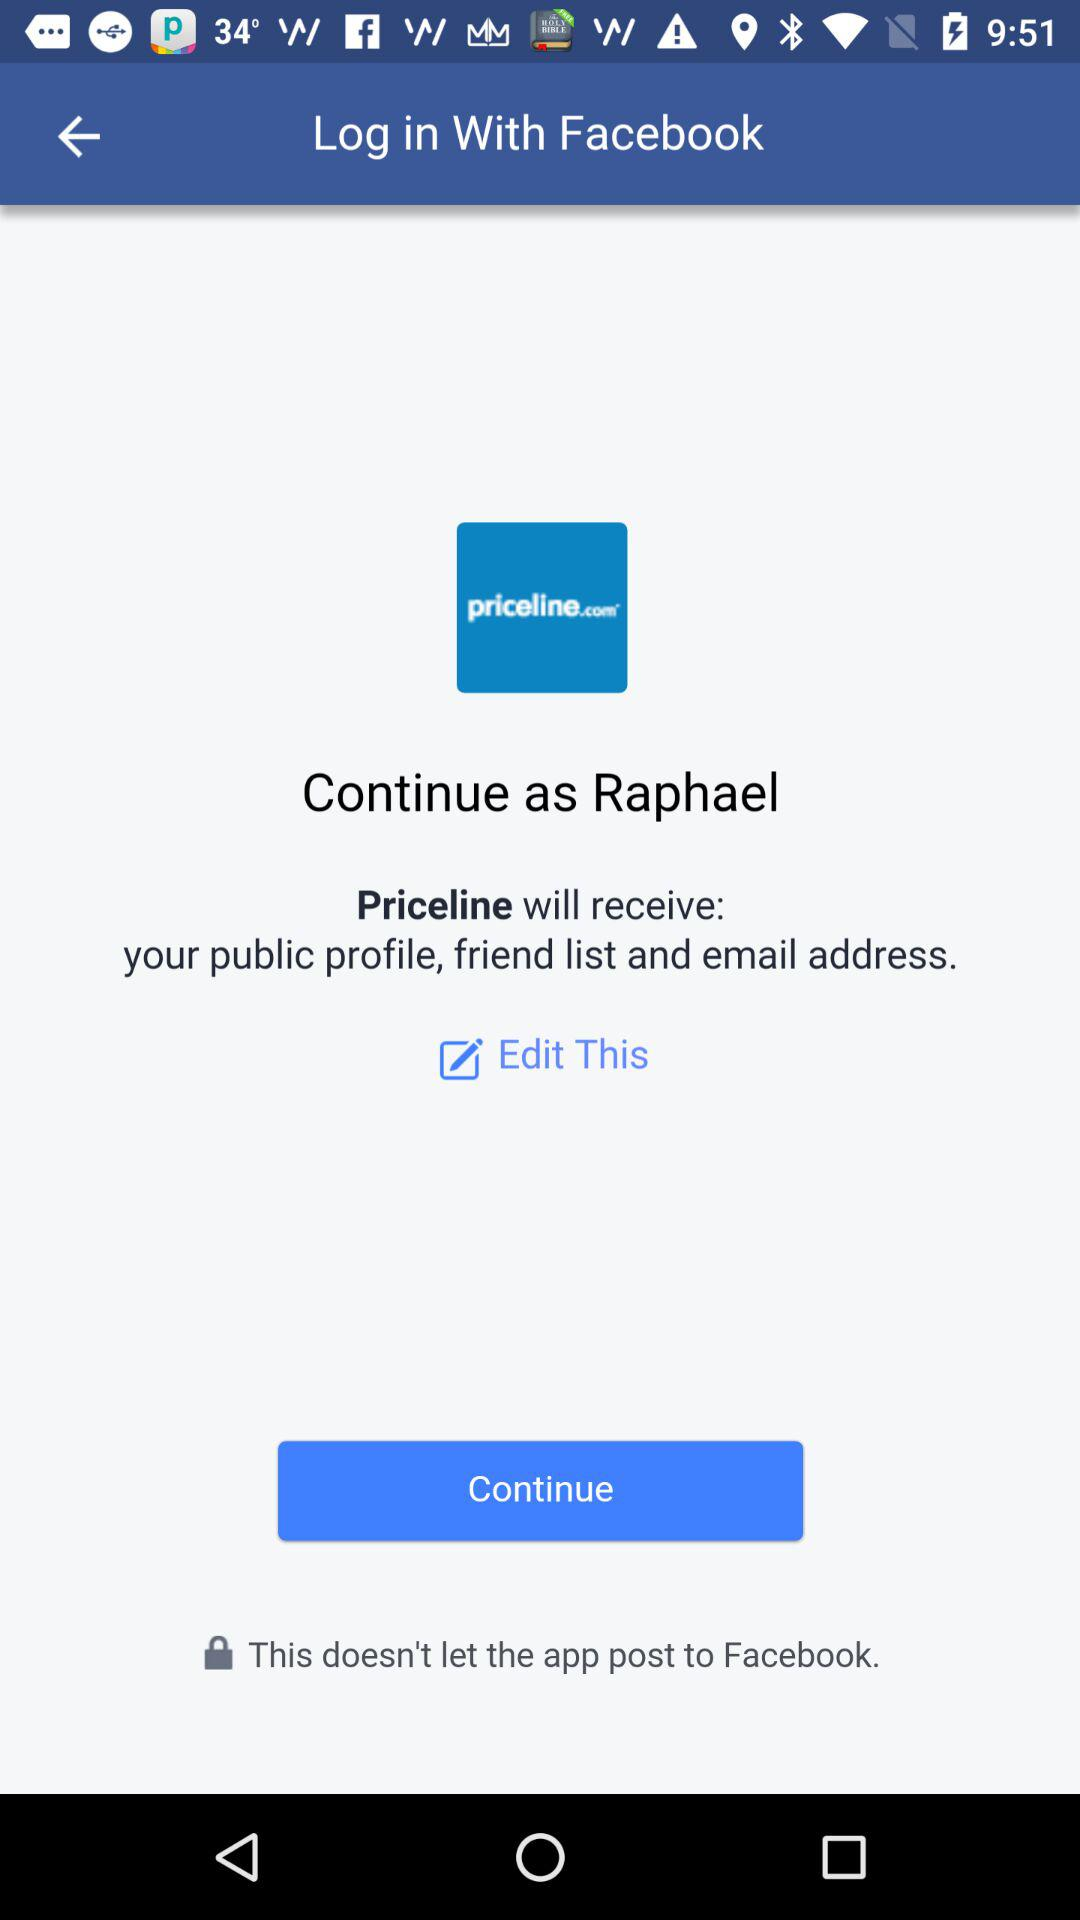What application will receive my public profile, email address and friend list? The application is "Priceline". 